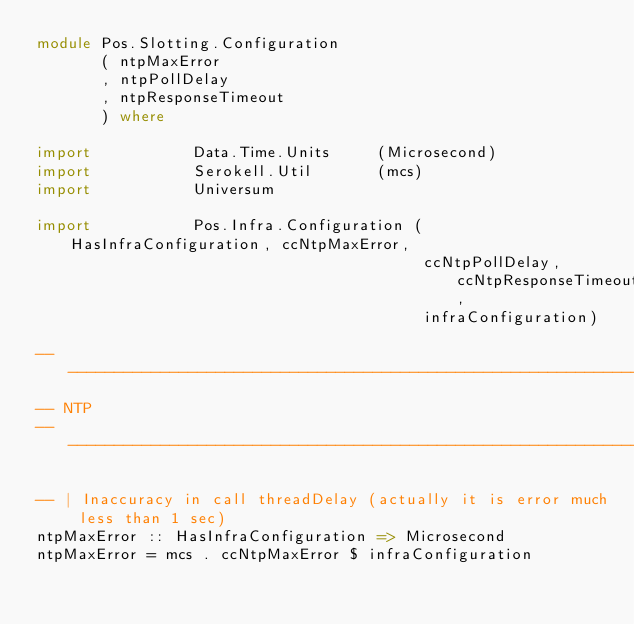Convert code to text. <code><loc_0><loc_0><loc_500><loc_500><_Haskell_>module Pos.Slotting.Configuration
       ( ntpMaxError
       , ntpPollDelay
       , ntpResponseTimeout
       ) where

import           Data.Time.Units     (Microsecond)
import           Serokell.Util       (mcs)
import           Universum

import           Pos.Infra.Configuration (HasInfraConfiguration, ccNtpMaxError,
                                          ccNtpPollDelay, ccNtpResponseTimeout,
                                          infraConfiguration)

----------------------------------------------------------------------------
-- NTP
----------------------------------------------------------------------------

-- | Inaccuracy in call threadDelay (actually it is error much less than 1 sec)
ntpMaxError :: HasInfraConfiguration => Microsecond
ntpMaxError = mcs . ccNtpMaxError $ infraConfiguration
</code> 